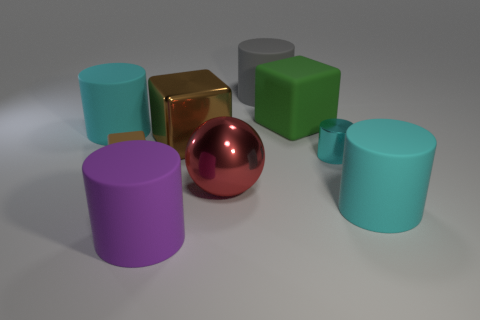Do the objects cast any shadows, and what does that tell us about the lighting in the scene? Yes, each object casts a soft shadow, indicating that there is a light source above and slightly to the right of the scene. The shadows help give a sense of depth and position to the objects in this three-dimensional space. 